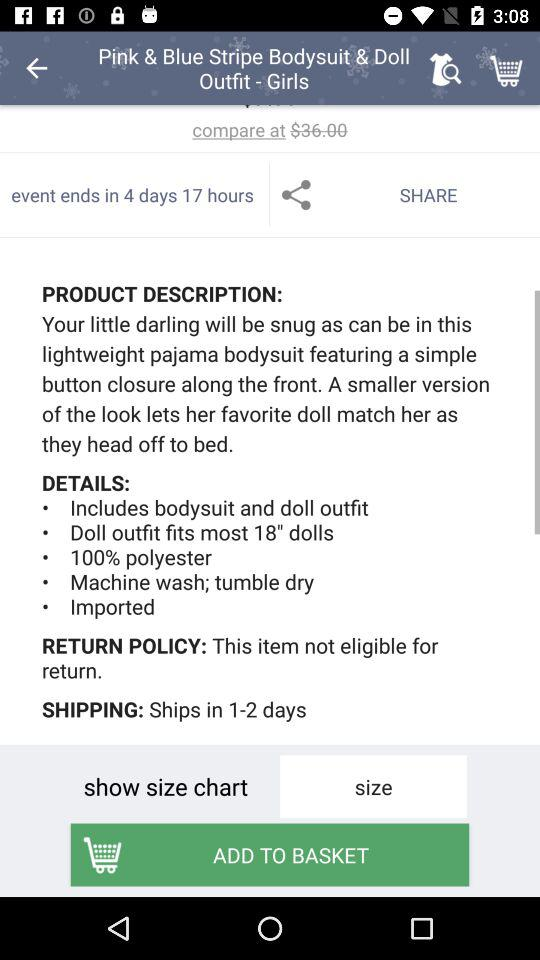What is the time duration until the event ends? The time duration until the event ends is 4 days 17 hours. 